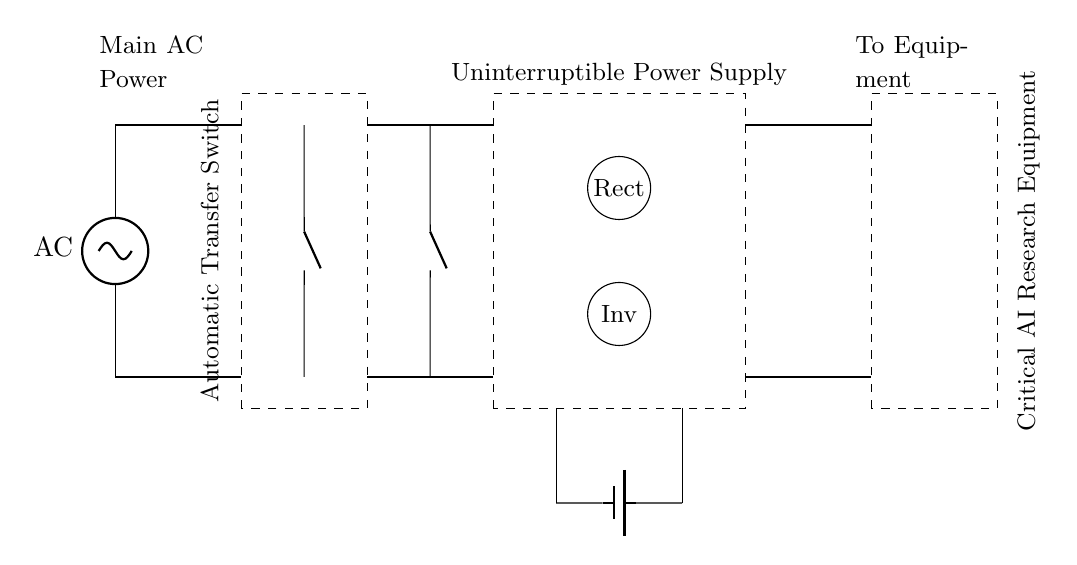What is the main power source for this circuit? The main power source is represented by the AC supply at the leftmost part of the circuit diagram. It provides the initial voltage necessary for the circuit to operate.
Answer: AC What is the function of the automatic transfer switch? The automatic transfer switch is used to switch between the main AC power and the backup power source (the UPS) seamlessly when a power failure or fluctuation occurs. It ensures the critical equipment remains powered without interruption.
Answer: Switching What component is used to store energy when AC power is unavailable? A battery is used in the UPS section of the circuit to store energy, providing power to the critical equipment when the AC power is interrupted.
Answer: Battery How many main switches are present in the circuit? There are two main switches, which are indicated by the nos symbols placed above the automatic transfer switch. These allow for control over the power sources.
Answer: Two What type of power does the inverter convert the stored energy to? The inverter converts the DC energy stored in the battery into AC power, which is then utilized by the critical AI research equipment.
Answer: AC How does the circuit ensure continuous power supply to critical equipment? The circuit incorporates an automatic transfer switch and a UPS. In the event of an AC power loss, the UPS uses its battery to supply power, while the transfer switch ensures that the power source changes without interrupting the flow to the equipment.
Answer: Continuous power 